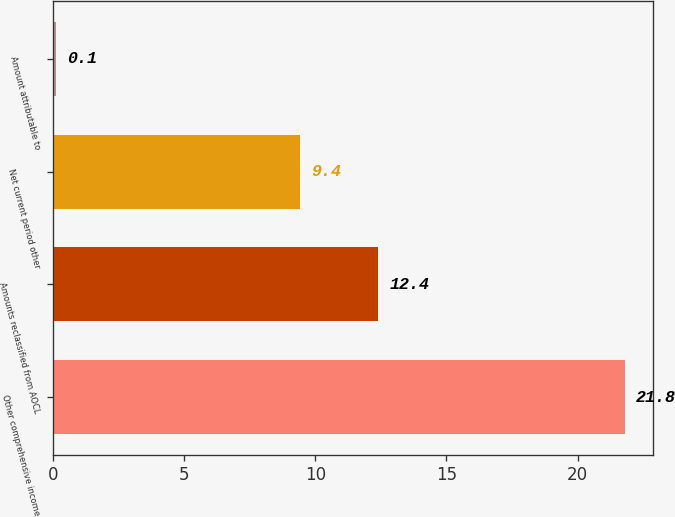Convert chart. <chart><loc_0><loc_0><loc_500><loc_500><bar_chart><fcel>Other comprehensive income<fcel>Amounts reclassified from AOCL<fcel>Net current period other<fcel>Amount attributable to<nl><fcel>21.8<fcel>12.4<fcel>9.4<fcel>0.1<nl></chart> 